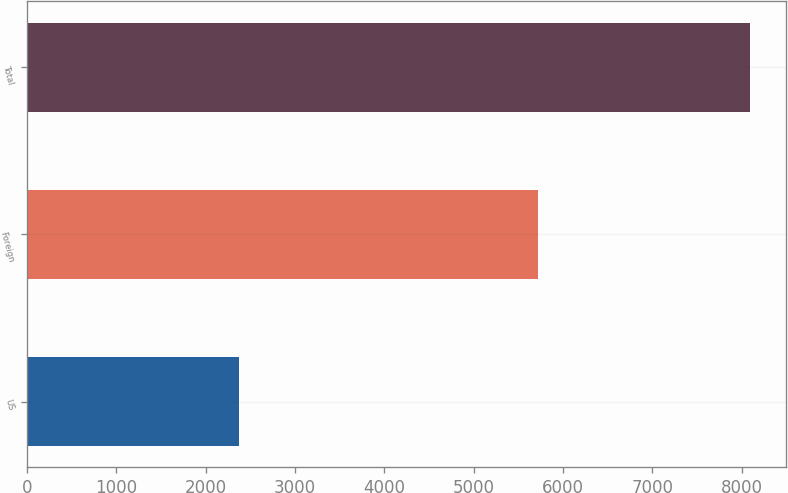<chart> <loc_0><loc_0><loc_500><loc_500><bar_chart><fcel>US<fcel>Foreign<fcel>Total<nl><fcel>2373<fcel>5720<fcel>8093<nl></chart> 